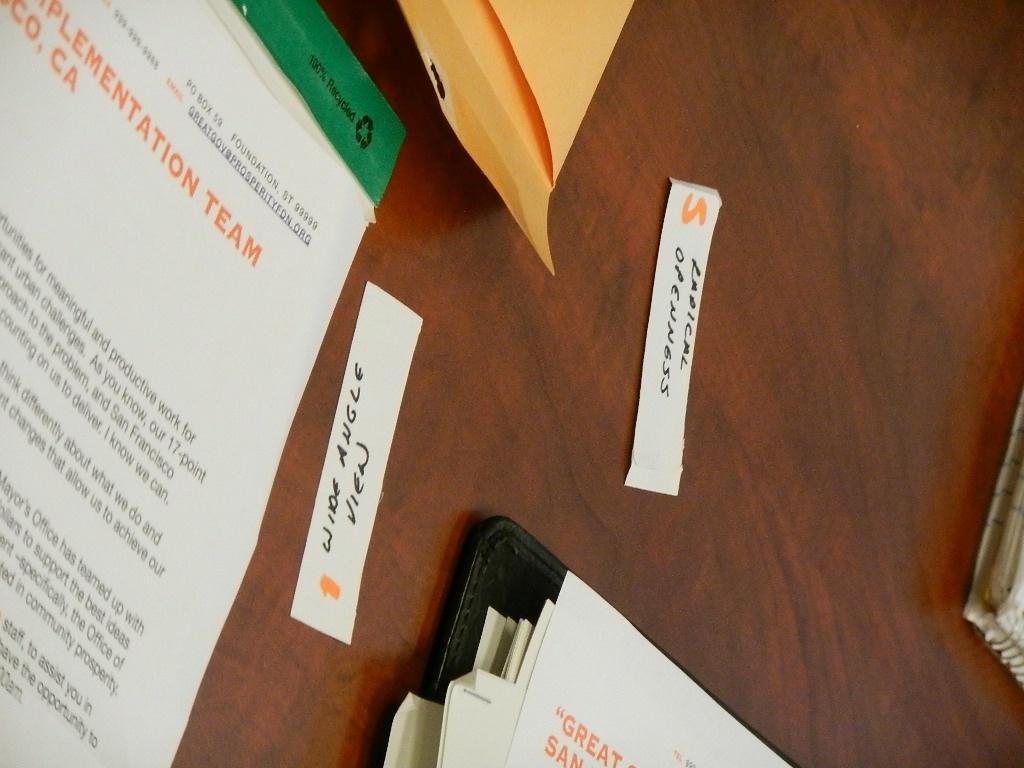Which state is the paper from?
Ensure brevity in your answer.  California. 